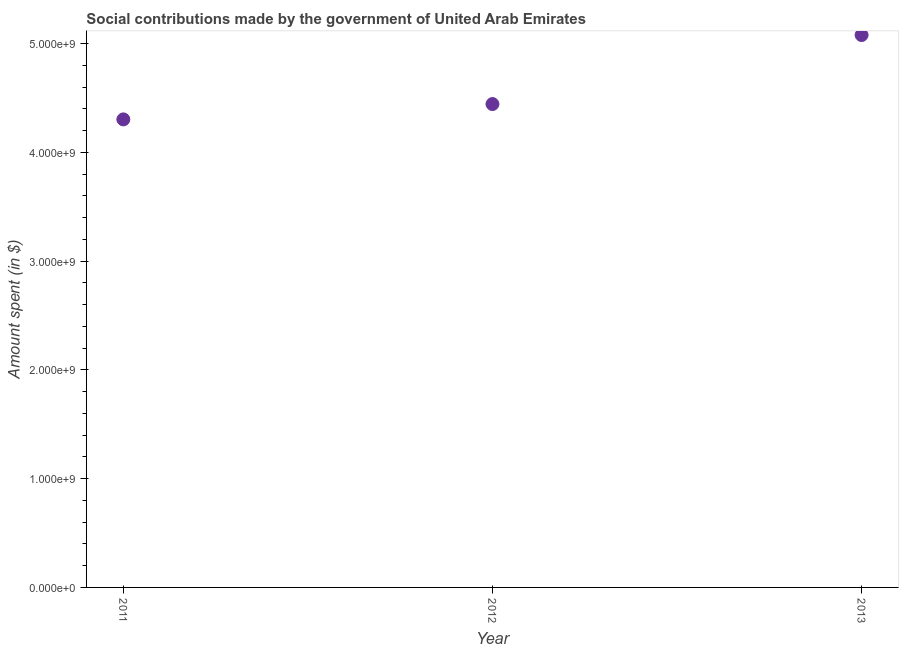What is the amount spent in making social contributions in 2013?
Provide a succinct answer. 5.08e+09. Across all years, what is the maximum amount spent in making social contributions?
Make the answer very short. 5.08e+09. Across all years, what is the minimum amount spent in making social contributions?
Your response must be concise. 4.30e+09. In which year was the amount spent in making social contributions maximum?
Provide a short and direct response. 2013. What is the sum of the amount spent in making social contributions?
Offer a very short reply. 1.38e+1. What is the difference between the amount spent in making social contributions in 2012 and 2013?
Your answer should be compact. -6.35e+08. What is the average amount spent in making social contributions per year?
Your answer should be compact. 4.61e+09. What is the median amount spent in making social contributions?
Provide a succinct answer. 4.44e+09. Do a majority of the years between 2013 and 2012 (inclusive) have amount spent in making social contributions greater than 3200000000 $?
Your answer should be very brief. No. What is the ratio of the amount spent in making social contributions in 2012 to that in 2013?
Keep it short and to the point. 0.88. Is the amount spent in making social contributions in 2011 less than that in 2012?
Provide a short and direct response. Yes. Is the difference between the amount spent in making social contributions in 2011 and 2012 greater than the difference between any two years?
Keep it short and to the point. No. What is the difference between the highest and the second highest amount spent in making social contributions?
Your response must be concise. 6.35e+08. Is the sum of the amount spent in making social contributions in 2012 and 2013 greater than the maximum amount spent in making social contributions across all years?
Offer a very short reply. Yes. What is the difference between the highest and the lowest amount spent in making social contributions?
Provide a short and direct response. 7.76e+08. Are the values on the major ticks of Y-axis written in scientific E-notation?
Ensure brevity in your answer.  Yes. What is the title of the graph?
Your answer should be very brief. Social contributions made by the government of United Arab Emirates. What is the label or title of the Y-axis?
Your response must be concise. Amount spent (in $). What is the Amount spent (in $) in 2011?
Keep it short and to the point. 4.30e+09. What is the Amount spent (in $) in 2012?
Keep it short and to the point. 4.44e+09. What is the Amount spent (in $) in 2013?
Your answer should be very brief. 5.08e+09. What is the difference between the Amount spent (in $) in 2011 and 2012?
Provide a succinct answer. -1.41e+08. What is the difference between the Amount spent (in $) in 2011 and 2013?
Provide a short and direct response. -7.76e+08. What is the difference between the Amount spent (in $) in 2012 and 2013?
Make the answer very short. -6.35e+08. What is the ratio of the Amount spent (in $) in 2011 to that in 2013?
Keep it short and to the point. 0.85. What is the ratio of the Amount spent (in $) in 2012 to that in 2013?
Provide a short and direct response. 0.88. 